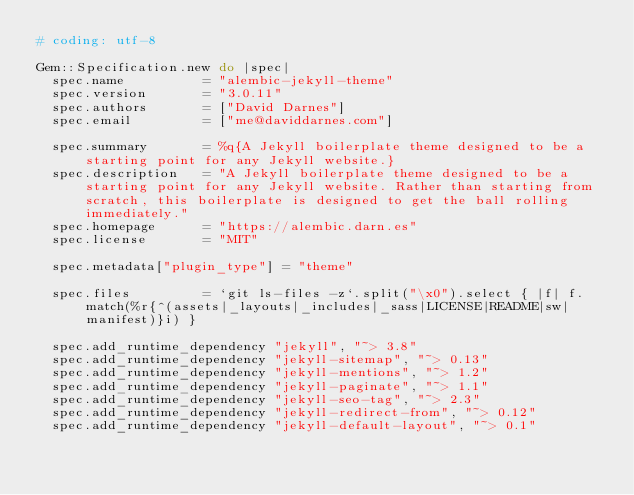<code> <loc_0><loc_0><loc_500><loc_500><_Ruby_># coding: utf-8

Gem::Specification.new do |spec|
  spec.name          = "alembic-jekyll-theme"
  spec.version       = "3.0.11"
  spec.authors       = ["David Darnes"]
  spec.email         = ["me@daviddarnes.com"]

  spec.summary       = %q{A Jekyll boilerplate theme designed to be a starting point for any Jekyll website.}
  spec.description   = "A Jekyll boilerplate theme designed to be a starting point for any Jekyll website. Rather than starting from scratch, this boilerplate is designed to get the ball rolling immediately."
  spec.homepage      = "https://alembic.darn.es"
  spec.license       = "MIT"

  spec.metadata["plugin_type"] = "theme"

  spec.files         = `git ls-files -z`.split("\x0").select { |f| f.match(%r{^(assets|_layouts|_includes|_sass|LICENSE|README|sw|manifest)}i) }

  spec.add_runtime_dependency "jekyll", "~> 3.8"
  spec.add_runtime_dependency "jekyll-sitemap", "~> 0.13"
  spec.add_runtime_dependency "jekyll-mentions", "~> 1.2"
  spec.add_runtime_dependency "jekyll-paginate", "~> 1.1"
  spec.add_runtime_dependency "jekyll-seo-tag", "~> 2.3"
  spec.add_runtime_dependency "jekyll-redirect-from", "~> 0.12"
  spec.add_runtime_dependency "jekyll-default-layout", "~> 0.1"</code> 